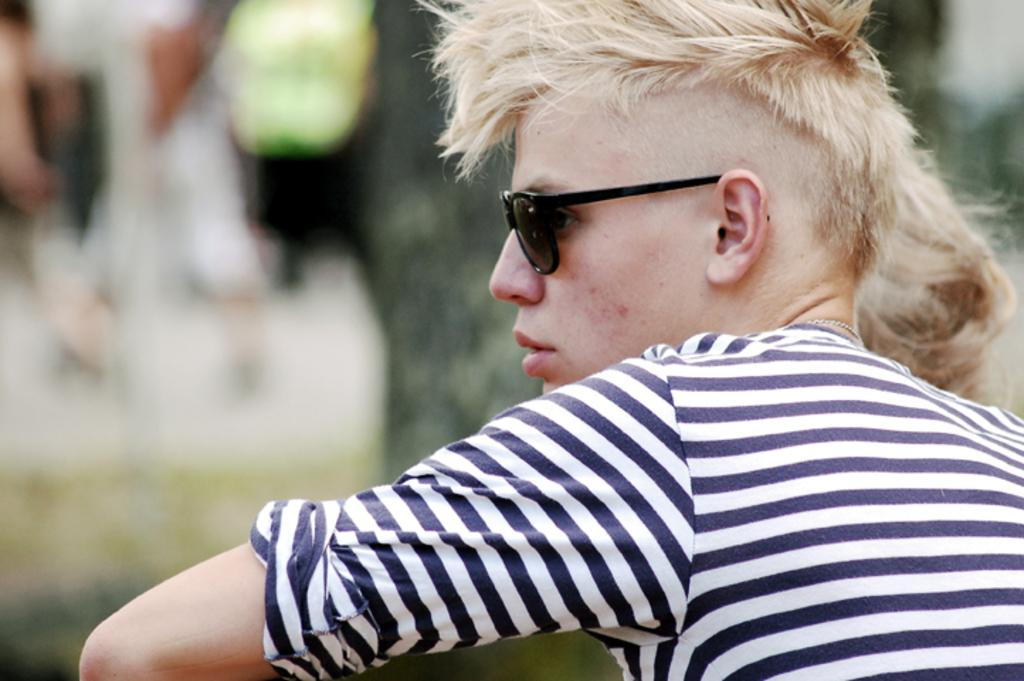Who or what is the main subject of the image? There is a person in the image. What can be observed about the person's appearance? The person is wearing spectacles. Can you describe the background of the image? The background of the image is blurred. How many children are present in the image? There is no mention of children in the image, so it cannot be determined how many are present. 